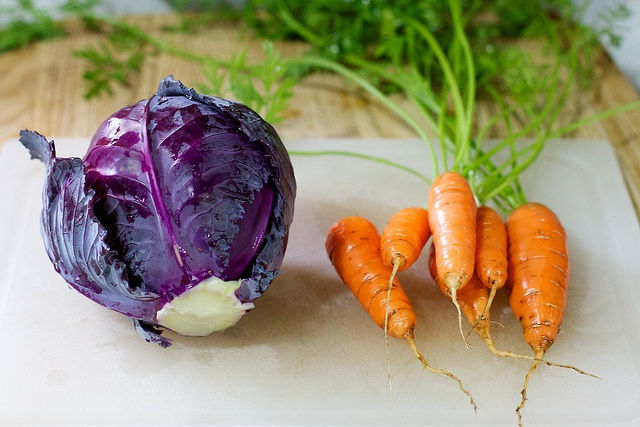Describe the objects in this image and their specific colors. I can see dining table in lightgray, tan, darkgray, and olive tones, carrot in lightblue, red, and orange tones, carrot in lightblue, red, orange, and brown tones, carrot in lightblue, orange, red, and tan tones, and carrot in lightblue, orange, red, and tan tones in this image. 